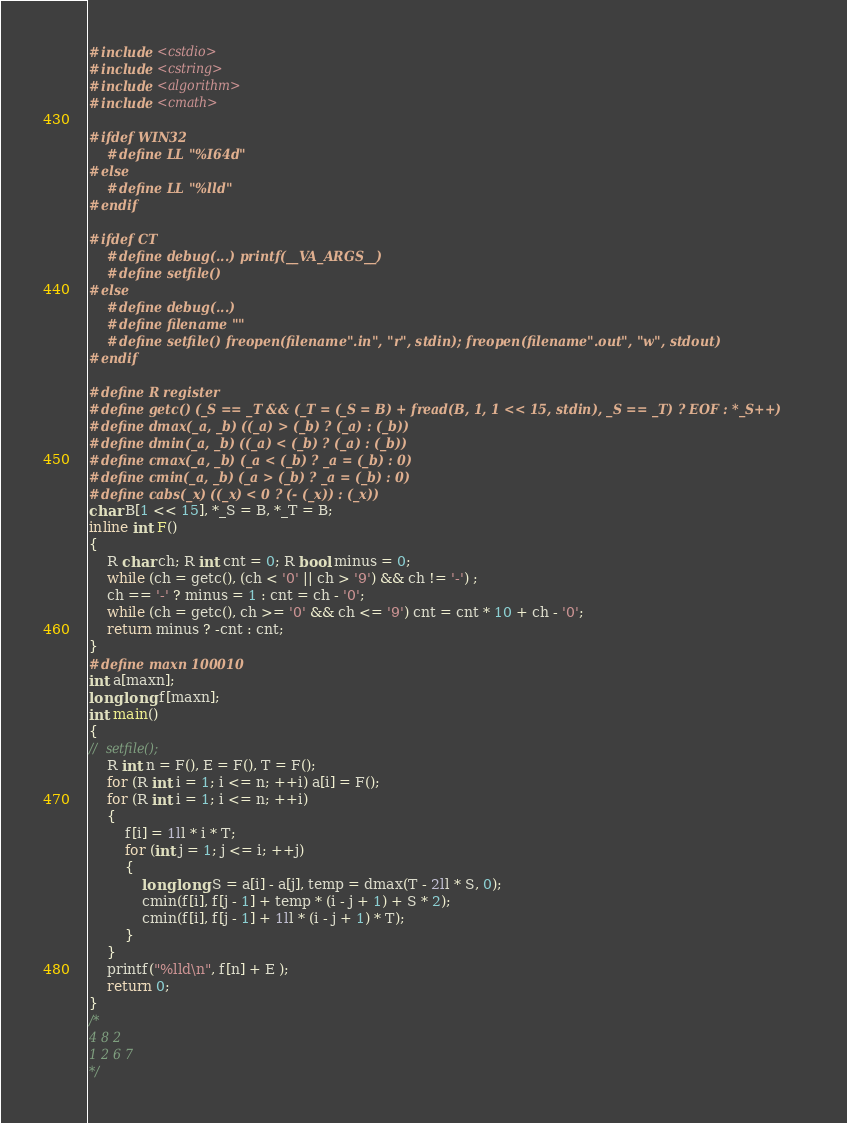<code> <loc_0><loc_0><loc_500><loc_500><_C++_>#include <cstdio>
#include <cstring>
#include <algorithm>
#include <cmath>

#ifdef WIN32
	#define LL "%I64d"
#else
	#define LL "%lld"
#endif

#ifdef CT
	#define debug(...) printf(__VA_ARGS__)
	#define setfile() 
#else
	#define debug(...)
	#define filename ""
	#define setfile() freopen(filename".in", "r", stdin); freopen(filename".out", "w", stdout)
#endif

#define R register
#define getc() (_S == _T && (_T = (_S = B) + fread(B, 1, 1 << 15, stdin), _S == _T) ? EOF : *_S++)
#define dmax(_a, _b) ((_a) > (_b) ? (_a) : (_b))
#define dmin(_a, _b) ((_a) < (_b) ? (_a) : (_b))
#define cmax(_a, _b) (_a < (_b) ? _a = (_b) : 0)
#define cmin(_a, _b) (_a > (_b) ? _a = (_b) : 0)
#define cabs(_x) ((_x) < 0 ? (- (_x)) : (_x))
char B[1 << 15], *_S = B, *_T = B;
inline int F()
{
	R char ch; R int cnt = 0; R bool minus = 0;
	while (ch = getc(), (ch < '0' || ch > '9') && ch != '-') ;
	ch == '-' ? minus = 1 : cnt = ch - '0';
	while (ch = getc(), ch >= '0' && ch <= '9') cnt = cnt * 10 + ch - '0';
	return minus ? -cnt : cnt;
}
#define maxn 100010
int a[maxn];
long long f[maxn];
int main()
{
//	setfile();
	R int n = F(), E = F(), T = F();
	for (R int i = 1; i <= n; ++i) a[i] = F();
	for (R int i = 1; i <= n; ++i)
	{
		f[i] = 1ll * i * T;
		for (int j = 1; j <= i; ++j)
		{
			long long S = a[i] - a[j], temp = dmax(T - 2ll * S, 0);
			cmin(f[i], f[j - 1] + temp * (i - j + 1) + S * 2);
			cmin(f[i], f[j - 1] + 1ll * (i - j + 1) * T);
		}
	}
	printf("%lld\n", f[n] + E );
	return 0;
}
/*
4 8 2
1 2 6 7
*/</code> 